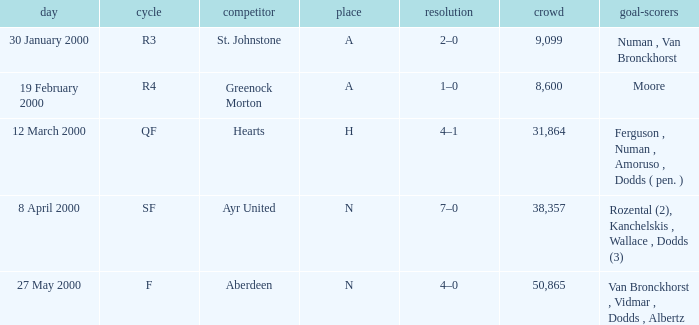Who was on 12 March 2000? Ferguson , Numan , Amoruso , Dodds ( pen. ). 